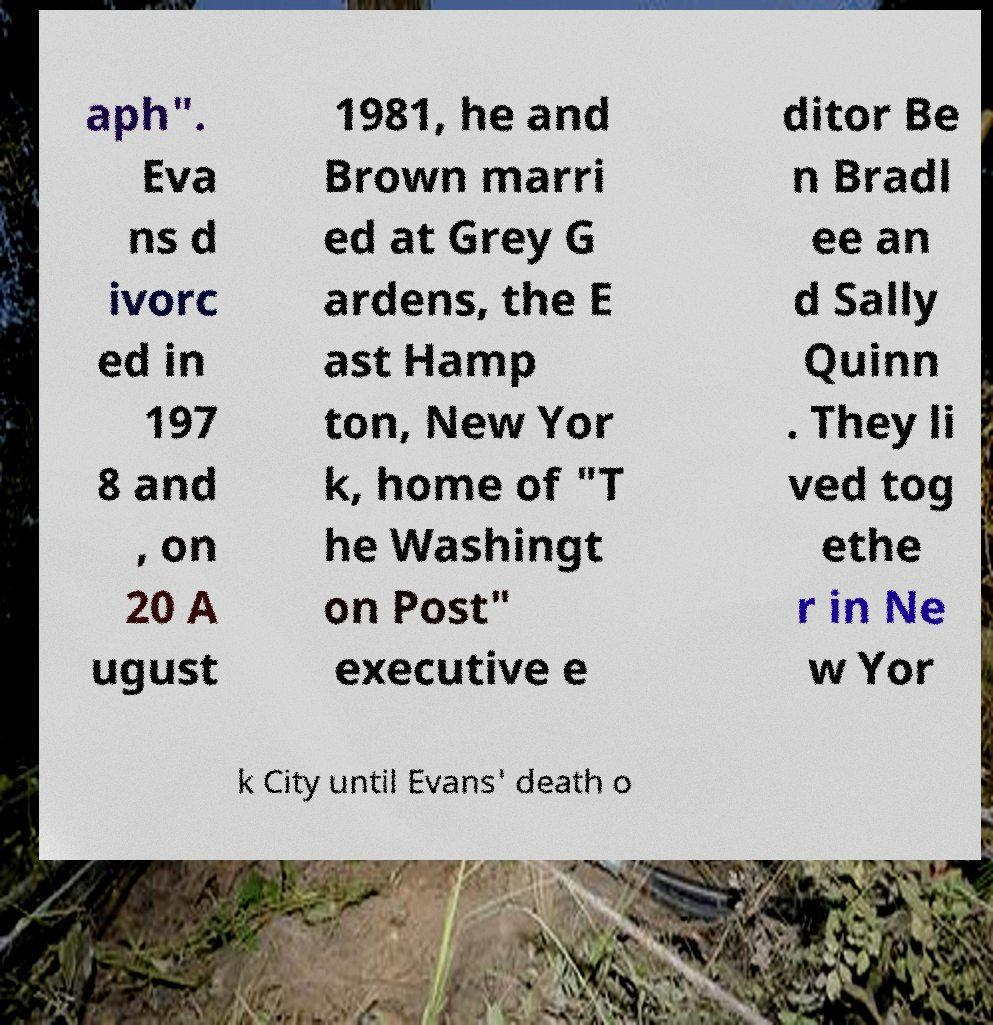What messages or text are displayed in this image? I need them in a readable, typed format. aph". Eva ns d ivorc ed in 197 8 and , on 20 A ugust 1981, he and Brown marri ed at Grey G ardens, the E ast Hamp ton, New Yor k, home of "T he Washingt on Post" executive e ditor Be n Bradl ee an d Sally Quinn . They li ved tog ethe r in Ne w Yor k City until Evans' death o 